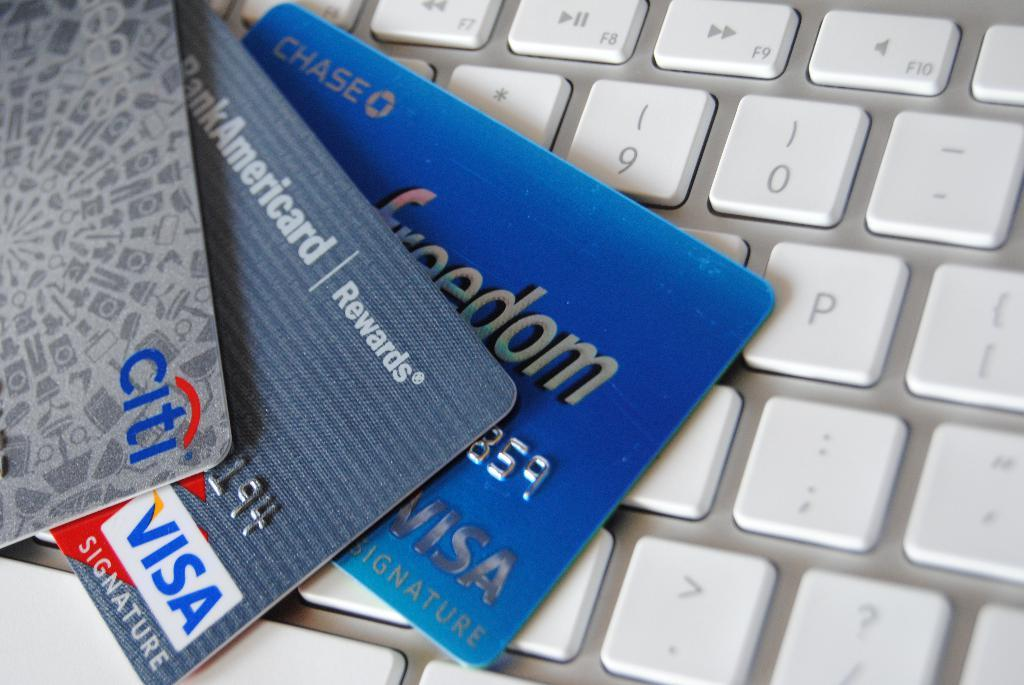<image>
Offer a succinct explanation of the picture presented. A citi card and two visa cards are fanned out on a white keyboard. 